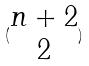Convert formula to latex. <formula><loc_0><loc_0><loc_500><loc_500>( \begin{matrix} n + 2 \\ 2 \end{matrix} )</formula> 